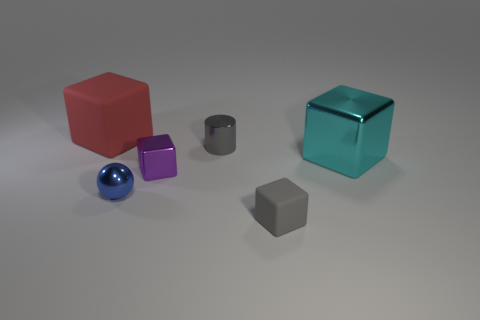Subtract all big cyan cubes. How many cubes are left? 3 Subtract all spheres. How many objects are left? 5 Subtract 4 cubes. How many cubes are left? 0 Subtract all purple cubes. Subtract all cyan cylinders. How many cubes are left? 3 Subtract all yellow spheres. How many cyan blocks are left? 1 Subtract all cylinders. Subtract all metallic cubes. How many objects are left? 3 Add 3 gray objects. How many gray objects are left? 5 Add 2 tiny purple metallic cubes. How many tiny purple metallic cubes exist? 3 Add 1 tiny cyan blocks. How many objects exist? 7 Subtract all cyan cubes. How many cubes are left? 3 